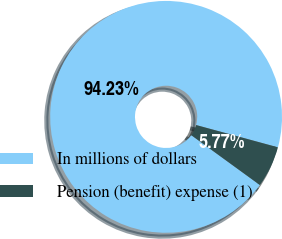Convert chart to OTSL. <chart><loc_0><loc_0><loc_500><loc_500><pie_chart><fcel>In millions of dollars<fcel>Pension (benefit) expense (1)<nl><fcel>94.23%<fcel>5.77%<nl></chart> 